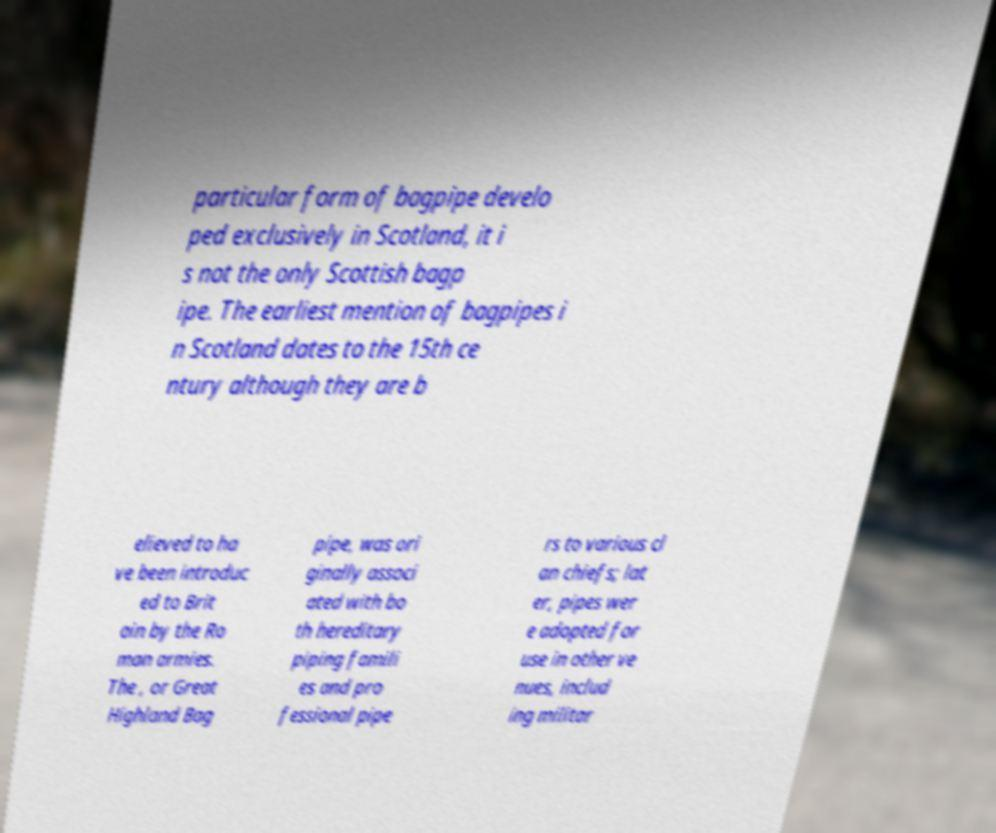Can you accurately transcribe the text from the provided image for me? particular form of bagpipe develo ped exclusively in Scotland, it i s not the only Scottish bagp ipe. The earliest mention of bagpipes i n Scotland dates to the 15th ce ntury although they are b elieved to ha ve been introduc ed to Brit ain by the Ro man armies. The , or Great Highland Bag pipe, was ori ginally associ ated with bo th hereditary piping famili es and pro fessional pipe rs to various cl an chiefs; lat er, pipes wer e adopted for use in other ve nues, includ ing militar 